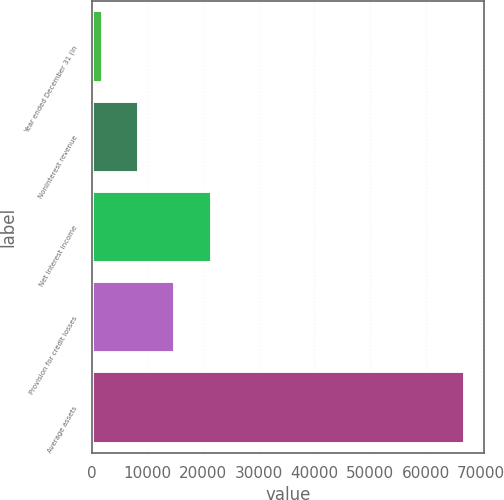Convert chart to OTSL. <chart><loc_0><loc_0><loc_500><loc_500><bar_chart><fcel>Year ended December 31 (in<fcel>Noninterest revenue<fcel>Net interest income<fcel>Provision for credit losses<fcel>Average assets<nl><fcel>2005<fcel>8522.5<fcel>21557.5<fcel>15040<fcel>67180<nl></chart> 